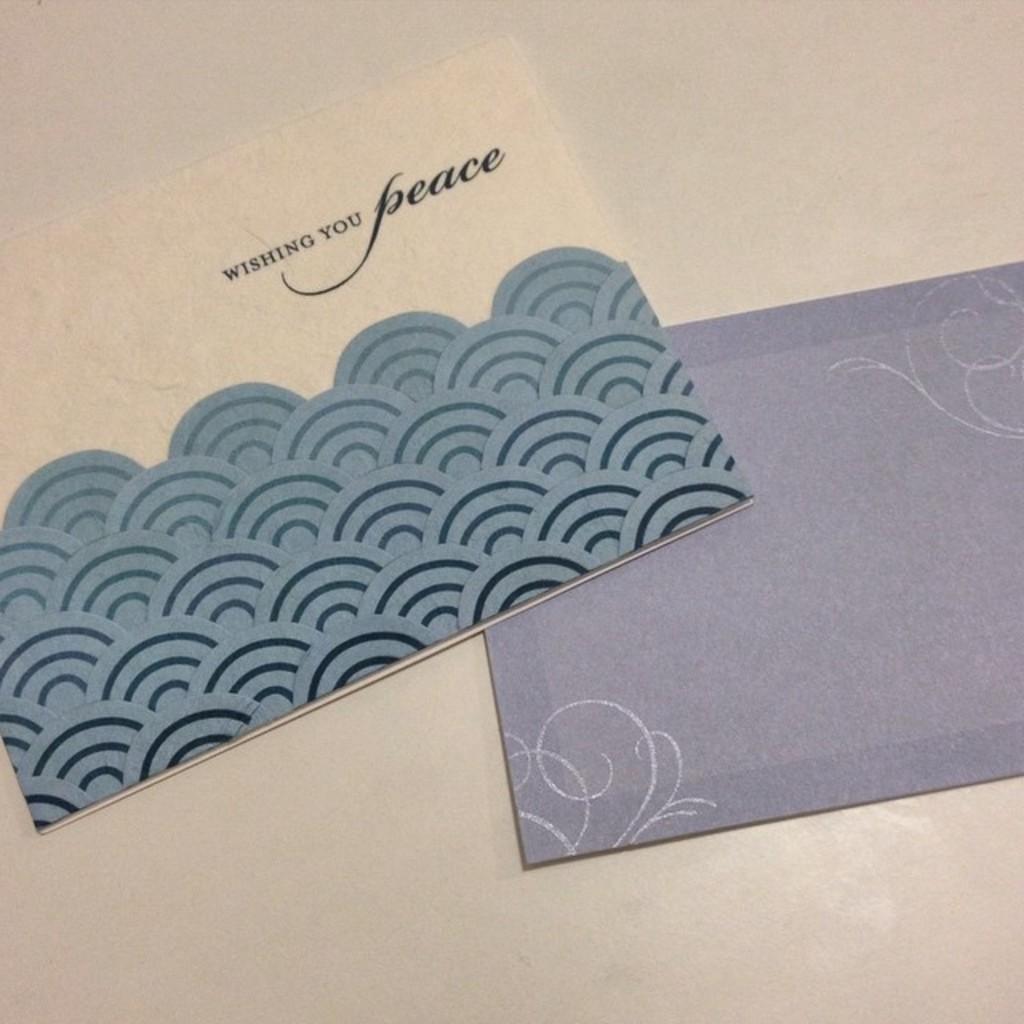In one or two sentences, can you explain what this image depicts? In this picture we can see envelopes and these envelopes are placed on a platform. 